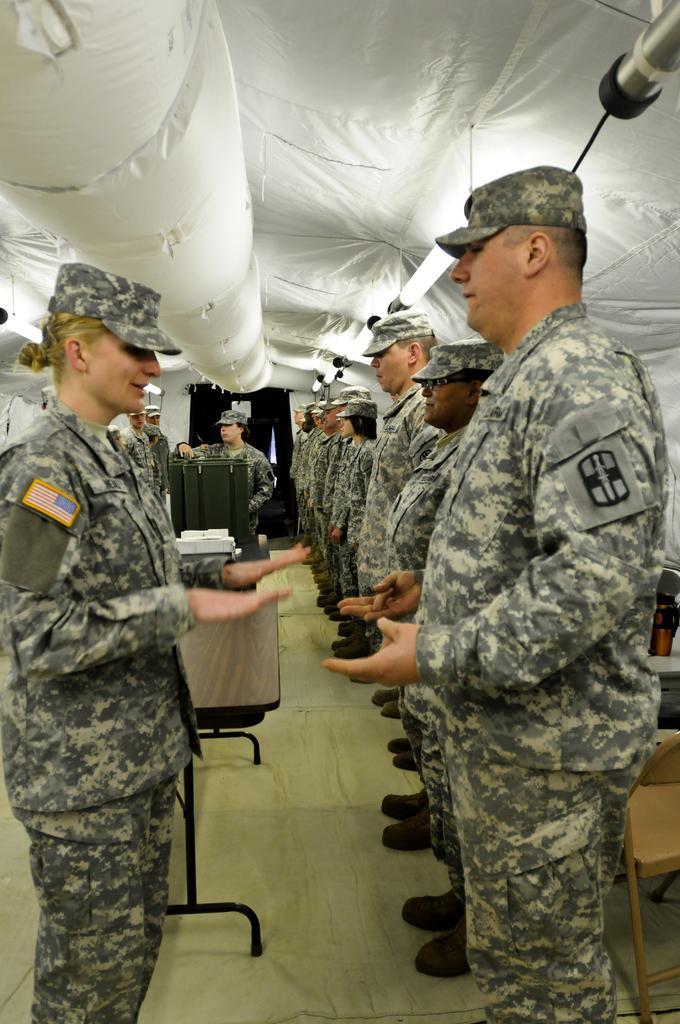Could you give a brief overview of what you see in this image? In the center of the image there are people standing wearing uniform. At the top of the image there is cloth. At the bottom of the image there is a floor. There is a table. 